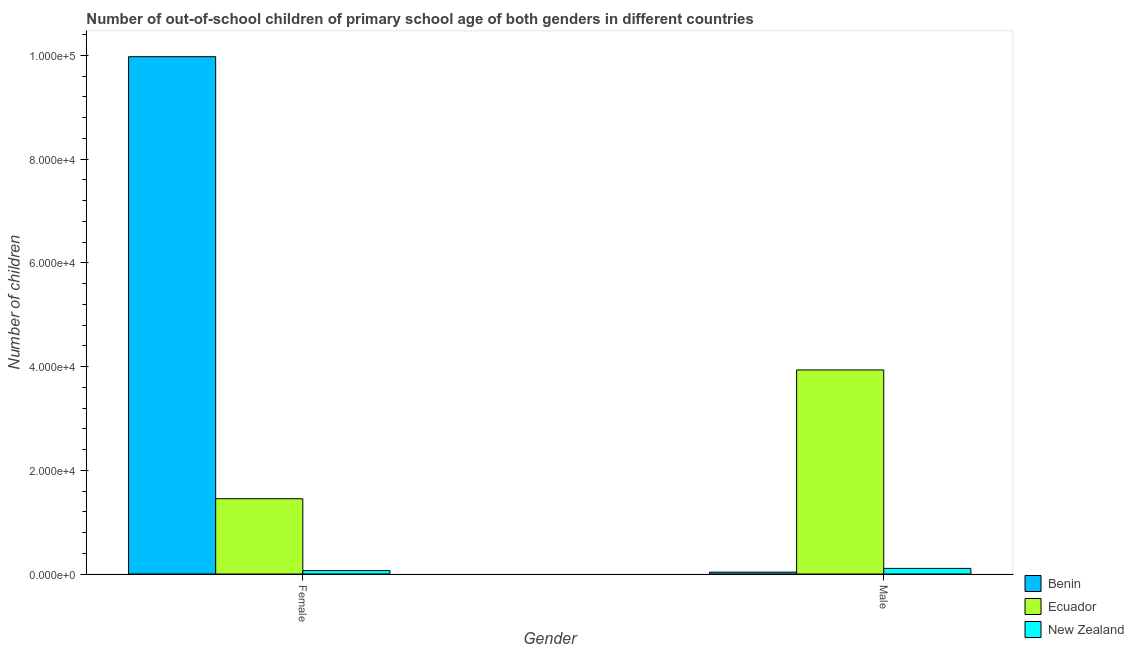How many different coloured bars are there?
Give a very brief answer. 3. Are the number of bars per tick equal to the number of legend labels?
Offer a terse response. Yes. Are the number of bars on each tick of the X-axis equal?
Your response must be concise. Yes. How many bars are there on the 2nd tick from the right?
Ensure brevity in your answer.  3. What is the label of the 1st group of bars from the left?
Provide a short and direct response. Female. What is the number of female out-of-school students in Benin?
Offer a very short reply. 9.97e+04. Across all countries, what is the maximum number of female out-of-school students?
Offer a terse response. 9.97e+04. Across all countries, what is the minimum number of male out-of-school students?
Offer a terse response. 355. In which country was the number of female out-of-school students maximum?
Your answer should be very brief. Benin. In which country was the number of female out-of-school students minimum?
Ensure brevity in your answer.  New Zealand. What is the total number of female out-of-school students in the graph?
Give a very brief answer. 1.15e+05. What is the difference between the number of female out-of-school students in Benin and that in Ecuador?
Provide a succinct answer. 8.52e+04. What is the difference between the number of male out-of-school students in New Zealand and the number of female out-of-school students in Ecuador?
Offer a terse response. -1.34e+04. What is the average number of female out-of-school students per country?
Provide a short and direct response. 3.83e+04. What is the difference between the number of male out-of-school students and number of female out-of-school students in New Zealand?
Provide a succinct answer. 423. What is the ratio of the number of female out-of-school students in Benin to that in New Zealand?
Your answer should be very brief. 151.11. In how many countries, is the number of male out-of-school students greater than the average number of male out-of-school students taken over all countries?
Your answer should be compact. 1. What does the 3rd bar from the left in Female represents?
Ensure brevity in your answer.  New Zealand. What does the 3rd bar from the right in Female represents?
Ensure brevity in your answer.  Benin. How many countries are there in the graph?
Keep it short and to the point. 3. What is the difference between two consecutive major ticks on the Y-axis?
Make the answer very short. 2.00e+04. Does the graph contain any zero values?
Offer a very short reply. No. How many legend labels are there?
Provide a succinct answer. 3. How are the legend labels stacked?
Keep it short and to the point. Vertical. What is the title of the graph?
Your answer should be compact. Number of out-of-school children of primary school age of both genders in different countries. Does "St. Lucia" appear as one of the legend labels in the graph?
Your response must be concise. No. What is the label or title of the X-axis?
Provide a succinct answer. Gender. What is the label or title of the Y-axis?
Your answer should be compact. Number of children. What is the Number of children in Benin in Female?
Provide a succinct answer. 9.97e+04. What is the Number of children of Ecuador in Female?
Provide a short and direct response. 1.45e+04. What is the Number of children of New Zealand in Female?
Your response must be concise. 660. What is the Number of children of Benin in Male?
Give a very brief answer. 355. What is the Number of children of Ecuador in Male?
Ensure brevity in your answer.  3.93e+04. What is the Number of children of New Zealand in Male?
Your response must be concise. 1083. Across all Gender, what is the maximum Number of children of Benin?
Offer a terse response. 9.97e+04. Across all Gender, what is the maximum Number of children of Ecuador?
Your answer should be very brief. 3.93e+04. Across all Gender, what is the maximum Number of children of New Zealand?
Ensure brevity in your answer.  1083. Across all Gender, what is the minimum Number of children in Benin?
Your answer should be very brief. 355. Across all Gender, what is the minimum Number of children in Ecuador?
Offer a terse response. 1.45e+04. Across all Gender, what is the minimum Number of children in New Zealand?
Ensure brevity in your answer.  660. What is the total Number of children of Benin in the graph?
Give a very brief answer. 1.00e+05. What is the total Number of children in Ecuador in the graph?
Provide a short and direct response. 5.38e+04. What is the total Number of children in New Zealand in the graph?
Offer a very short reply. 1743. What is the difference between the Number of children in Benin in Female and that in Male?
Your response must be concise. 9.94e+04. What is the difference between the Number of children of Ecuador in Female and that in Male?
Provide a short and direct response. -2.48e+04. What is the difference between the Number of children of New Zealand in Female and that in Male?
Give a very brief answer. -423. What is the difference between the Number of children in Benin in Female and the Number of children in Ecuador in Male?
Give a very brief answer. 6.04e+04. What is the difference between the Number of children in Benin in Female and the Number of children in New Zealand in Male?
Your response must be concise. 9.86e+04. What is the difference between the Number of children in Ecuador in Female and the Number of children in New Zealand in Male?
Offer a terse response. 1.34e+04. What is the average Number of children in Benin per Gender?
Provide a succinct answer. 5.00e+04. What is the average Number of children in Ecuador per Gender?
Provide a short and direct response. 2.69e+04. What is the average Number of children in New Zealand per Gender?
Give a very brief answer. 871.5. What is the difference between the Number of children of Benin and Number of children of Ecuador in Female?
Offer a terse response. 8.52e+04. What is the difference between the Number of children of Benin and Number of children of New Zealand in Female?
Your answer should be compact. 9.91e+04. What is the difference between the Number of children of Ecuador and Number of children of New Zealand in Female?
Your response must be concise. 1.38e+04. What is the difference between the Number of children of Benin and Number of children of Ecuador in Male?
Give a very brief answer. -3.90e+04. What is the difference between the Number of children of Benin and Number of children of New Zealand in Male?
Provide a succinct answer. -728. What is the difference between the Number of children of Ecuador and Number of children of New Zealand in Male?
Offer a terse response. 3.83e+04. What is the ratio of the Number of children of Benin in Female to that in Male?
Keep it short and to the point. 280.94. What is the ratio of the Number of children of Ecuador in Female to that in Male?
Your answer should be very brief. 0.37. What is the ratio of the Number of children of New Zealand in Female to that in Male?
Ensure brevity in your answer.  0.61. What is the difference between the highest and the second highest Number of children in Benin?
Your response must be concise. 9.94e+04. What is the difference between the highest and the second highest Number of children in Ecuador?
Your answer should be compact. 2.48e+04. What is the difference between the highest and the second highest Number of children in New Zealand?
Provide a short and direct response. 423. What is the difference between the highest and the lowest Number of children in Benin?
Offer a very short reply. 9.94e+04. What is the difference between the highest and the lowest Number of children in Ecuador?
Offer a terse response. 2.48e+04. What is the difference between the highest and the lowest Number of children in New Zealand?
Make the answer very short. 423. 